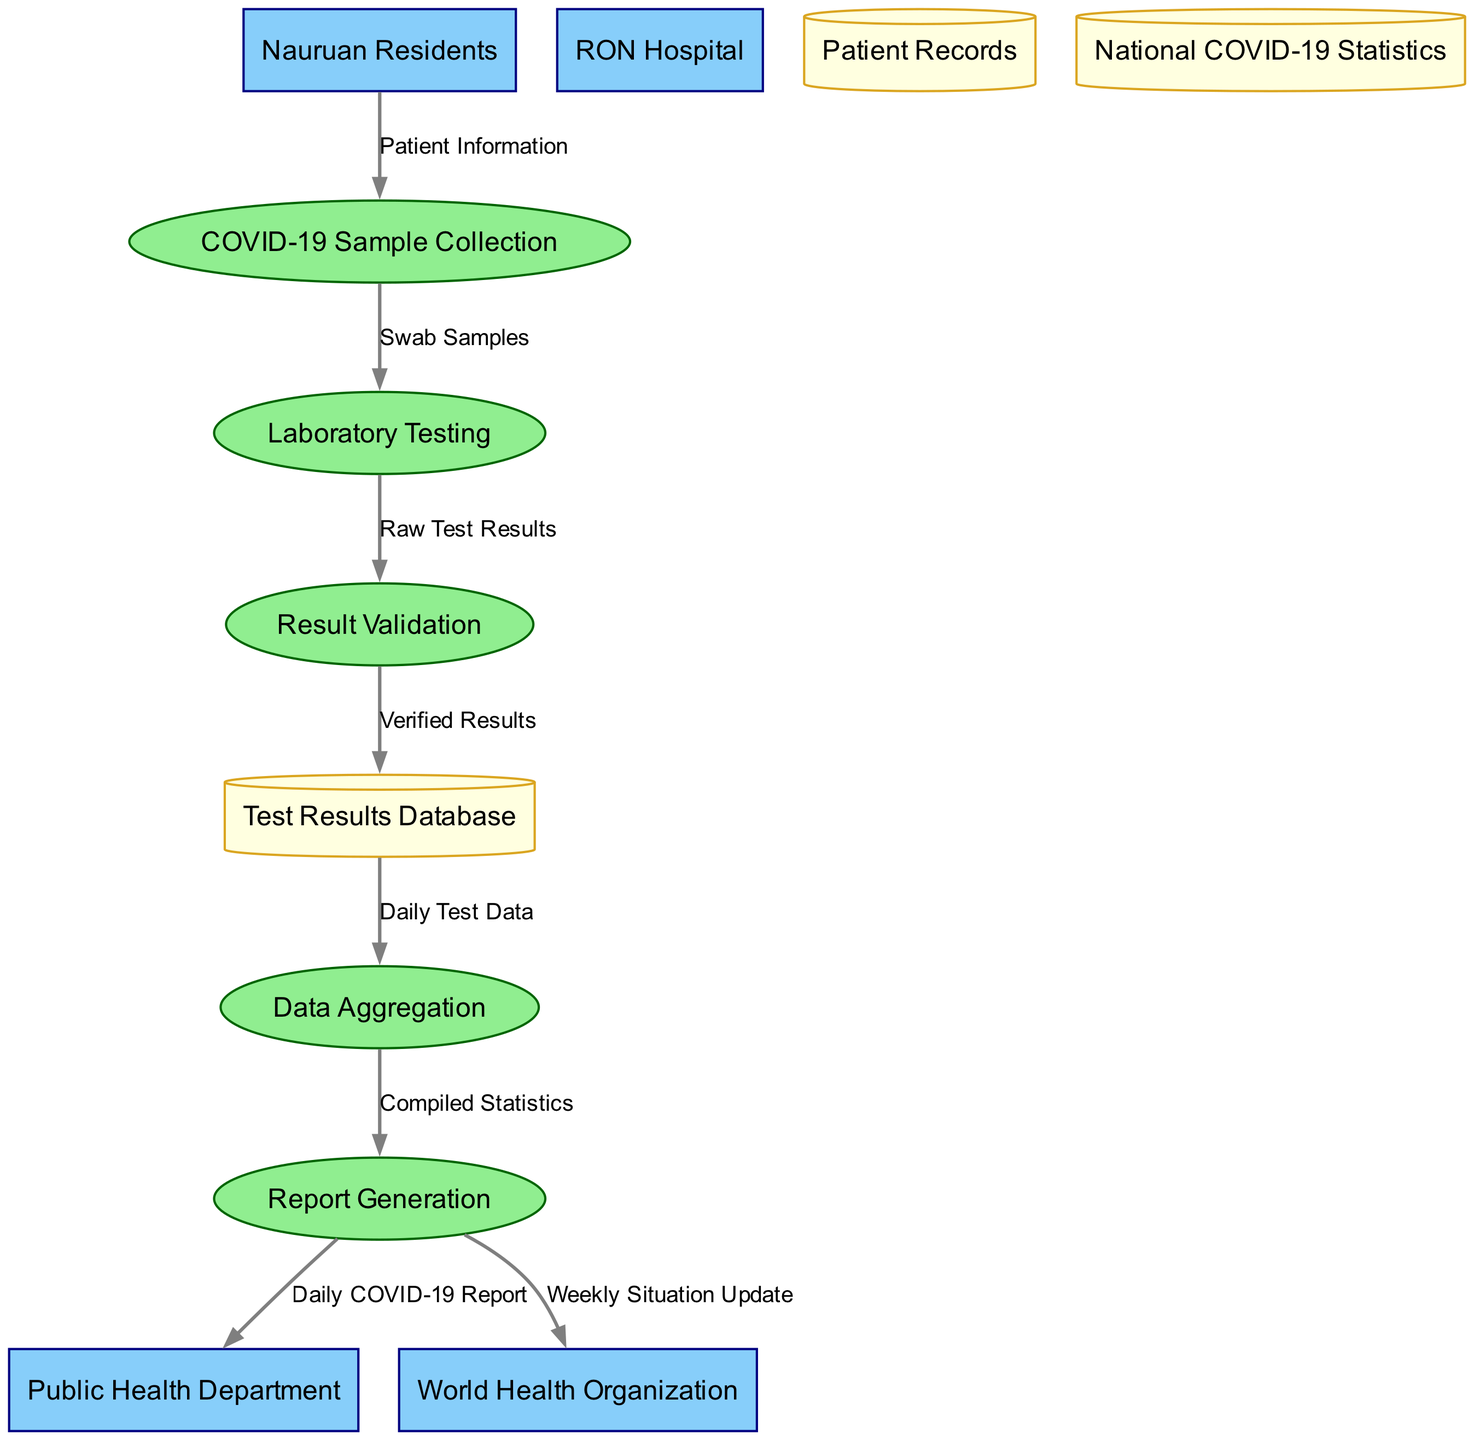What are the external entities in the diagram? The external entities listed in the diagram are the sources or stakeholders interacting with the processes depicted. They are "Nauruan Residents," "RON Hospital," "Public Health Department," and "World Health Organization."
Answer: Nauruan Residents, RON Hospital, Public Health Department, World Health Organization How many processes are there in the diagram? The diagram includes five distinct processes that represent the steps involved in the COVID-19 testing and reporting system, namely "COVID-19 Sample Collection," "Laboratory Testing," "Result Validation," "Data Aggregation," and "Report Generation."
Answer: Five What type of data does the "Laboratory Testing" process receive? The "Laboratory Testing" process receives "Swab Samples" from the "COVID-19 Sample Collection," which signifies the physical samples collected from residents for testing.
Answer: Swab Samples Which two entities receive the reports generated in the system? The "Report Generation" process outputs the "Daily COVID-19 Report" to the "Public Health Department" and the "Weekly Situation Update" to the "World Health Organization," indicating the communication of test results and statistics to these bodies.
Answer: Public Health Department, World Health Organization What is the flow of data from "Result Validation" to "Test Results Database?" The flow of data from "Result Validation" to "Test Results Database" consists of "Verified Results," meaning that the raw test results have been checked and confirmed before being stored for further use.
Answer: Verified Results How is the data transferred from "Test Results Database" to "Data Aggregation?" The "Data Aggregation" process receives "Daily Test Data" from the "Test Results Database," indicating the systematic collection and compiling of the test results on a day-to-day basis.
Answer: Daily Test Data What is the relationship between "COVID-19 Sample Collection" and "Laboratory Testing?" The relationship indicates that "COVID-19 Sample Collection" sends "Swab Samples" to "Laboratory Testing." This suggests a direct progression of samples taken from residents to where they are analyzed for COVID-19.
Answer: Swab Samples Which data store handles the aggregated statistics? The "Test Results Database" is responsible for storing the verified results, while "Data Aggregation" compiles and organizes this information into coherent statistics for reporting purposes.
Answer: Test Results Database What is the purpose of "Report Generation" in the flow? The "Report Generation" process is pivotal as it synthesizes information from the aggregated data, producing reports that are essential for informing both the Public Health Department and the World Health Organization about the COVID-19 situation.
Answer: Reports production 